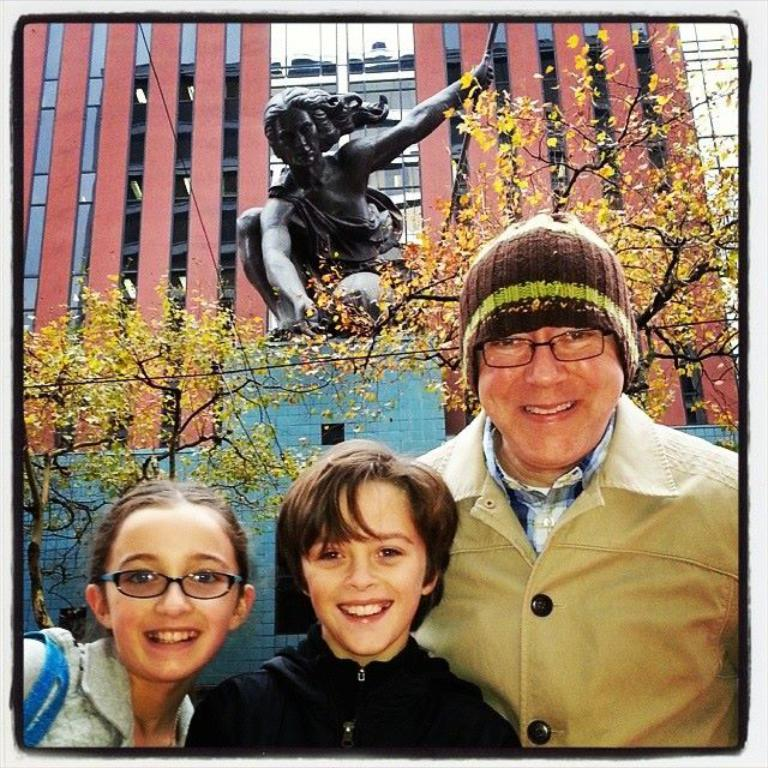How many people are in the image? There are three persons in the image. What are the expressions on the faces of the persons? The persons are smiling. What are the persons doing in the image? The persons are watching something. What can be seen in the background of the image? There are trees, a statue, a building, walls, and glass objects in the background of the image. What type of bait is being used by the persons in the image? There is no indication in the image that the persons are using any bait, as they are watching something and not engaging in any fishing or similar activities. 